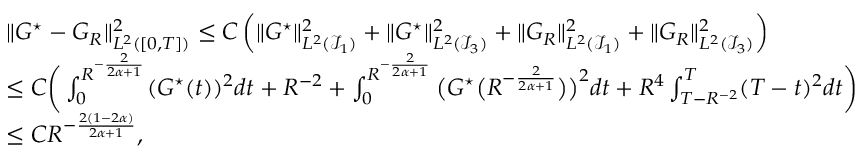<formula> <loc_0><loc_0><loc_500><loc_500>\begin{array} { r l } & { \| G ^ { ^ { * } } - { G } _ { R } \| _ { L ^ { 2 } ( [ 0 , T ] ) } ^ { 2 } \leq C \left ( \| G ^ { ^ { * } } \| _ { L ^ { 2 } ( \mathcal { I } _ { 1 } ) } ^ { 2 } + \| G ^ { ^ { * } } \| _ { L ^ { 2 } ( \mathcal { I } _ { 3 } ) } ^ { 2 } + \| G _ { R } \| _ { L ^ { 2 } ( \mathcal { I } _ { 1 } ) } ^ { 2 } + \| G _ { R } \| _ { L ^ { 2 } ( \mathcal { I } _ { 3 } ) } ^ { 2 } \right ) } \\ & { \leq C \left ( \int _ { 0 } ^ { R ^ { - \frac { 2 } { 2 \alpha + 1 } } } ( G ^ { ^ { * } } ( t ) ) ^ { 2 } d t + R ^ { - 2 } + \int _ { 0 } ^ { R ^ { - \frac { 2 } { 2 \alpha + 1 } } } \left ( G ^ { ^ { * } } \left ( R ^ { - \frac { 2 } { 2 \alpha + 1 } } \right ) \right ) ^ { 2 } d t + R ^ { 4 } \int _ { T - R ^ { - 2 } } ^ { T } ( T - t ) ^ { 2 } d t \right ) } \\ & { \leq C R ^ { - \frac { 2 ( 1 - 2 \alpha ) } { 2 \alpha + 1 } } , } \end{array}</formula> 